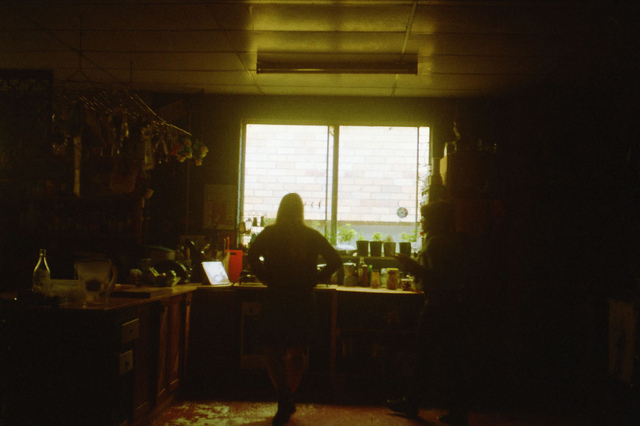<image>Is the hallway wide or narrow? I am not sure if the hallway is wide or narrow. Some responses suggest it is wide, but it could also be narrow or not visible at all. Is the hallway wide or narrow? I don't know if the hallway is wide or narrow. The answers are both wide and narrow. 